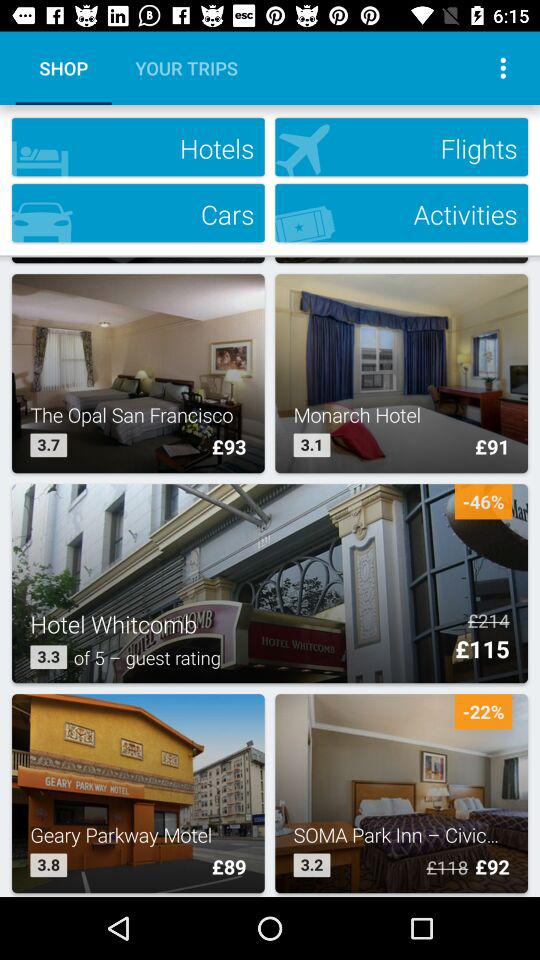What is the rating of "Hotel Whitcomb" given by guests? The rating given by guests is 3.3. 